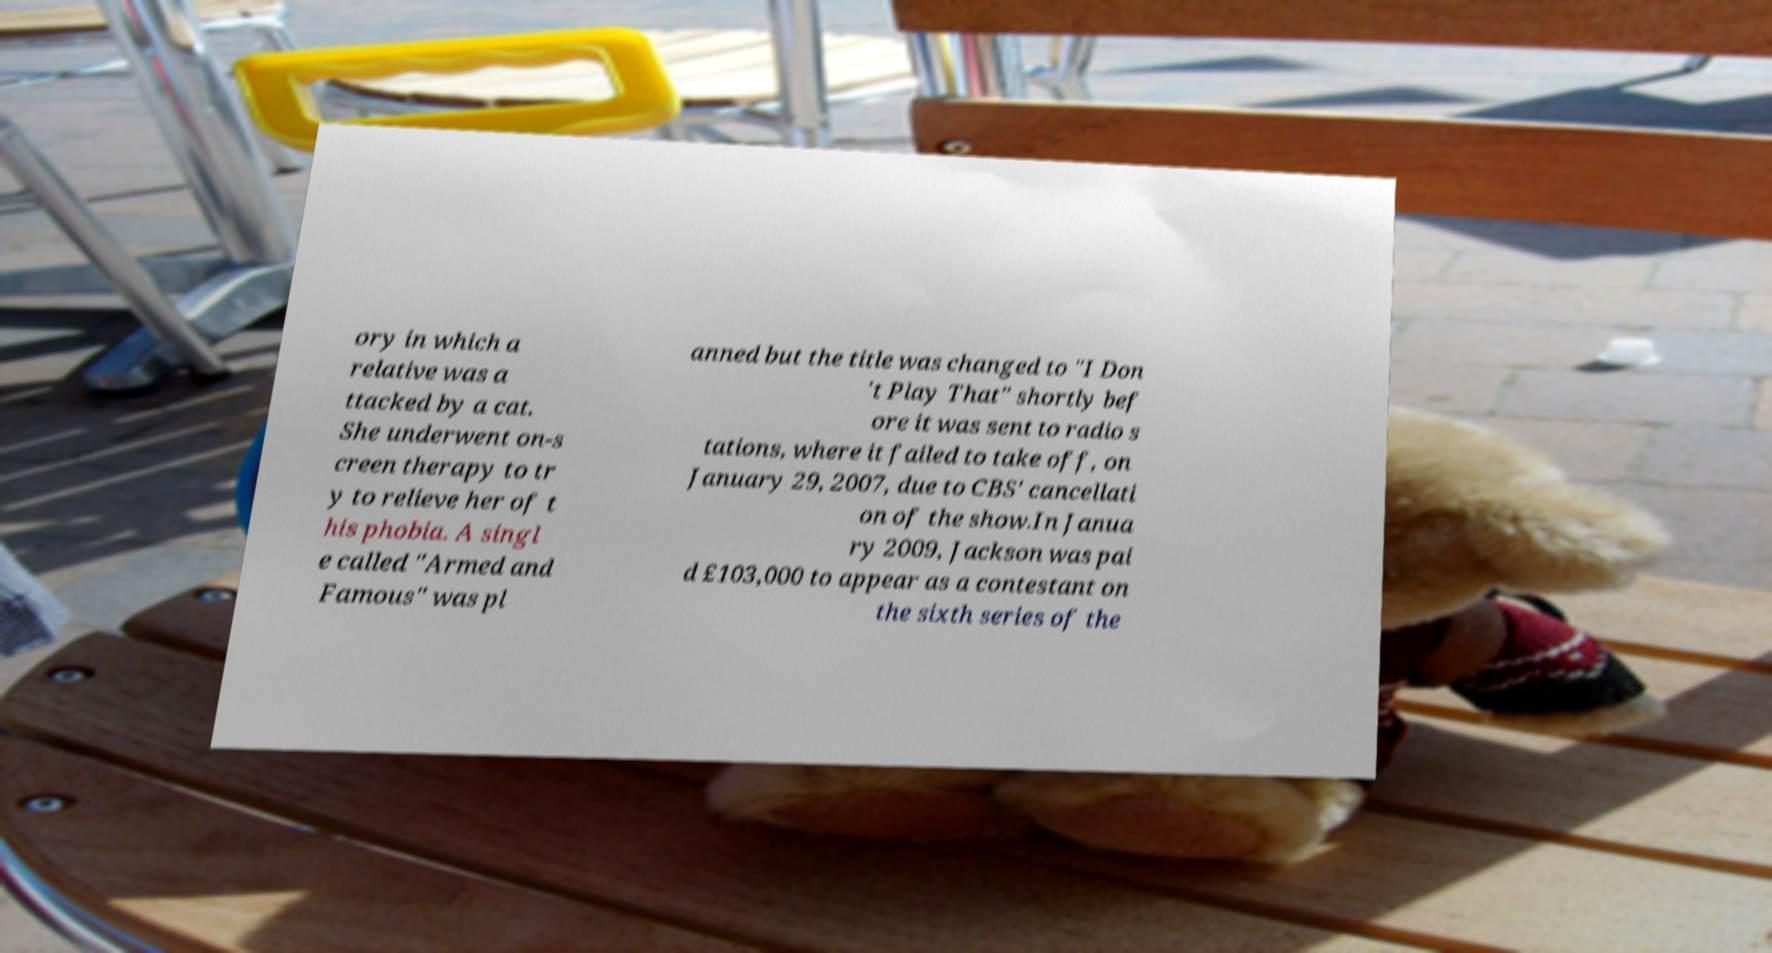For documentation purposes, I need the text within this image transcribed. Could you provide that? ory in which a relative was a ttacked by a cat. She underwent on-s creen therapy to tr y to relieve her of t his phobia. A singl e called "Armed and Famous" was pl anned but the title was changed to "I Don 't Play That" shortly bef ore it was sent to radio s tations, where it failed to take off, on January 29, 2007, due to CBS' cancellati on of the show.In Janua ry 2009, Jackson was pai d £103,000 to appear as a contestant on the sixth series of the 